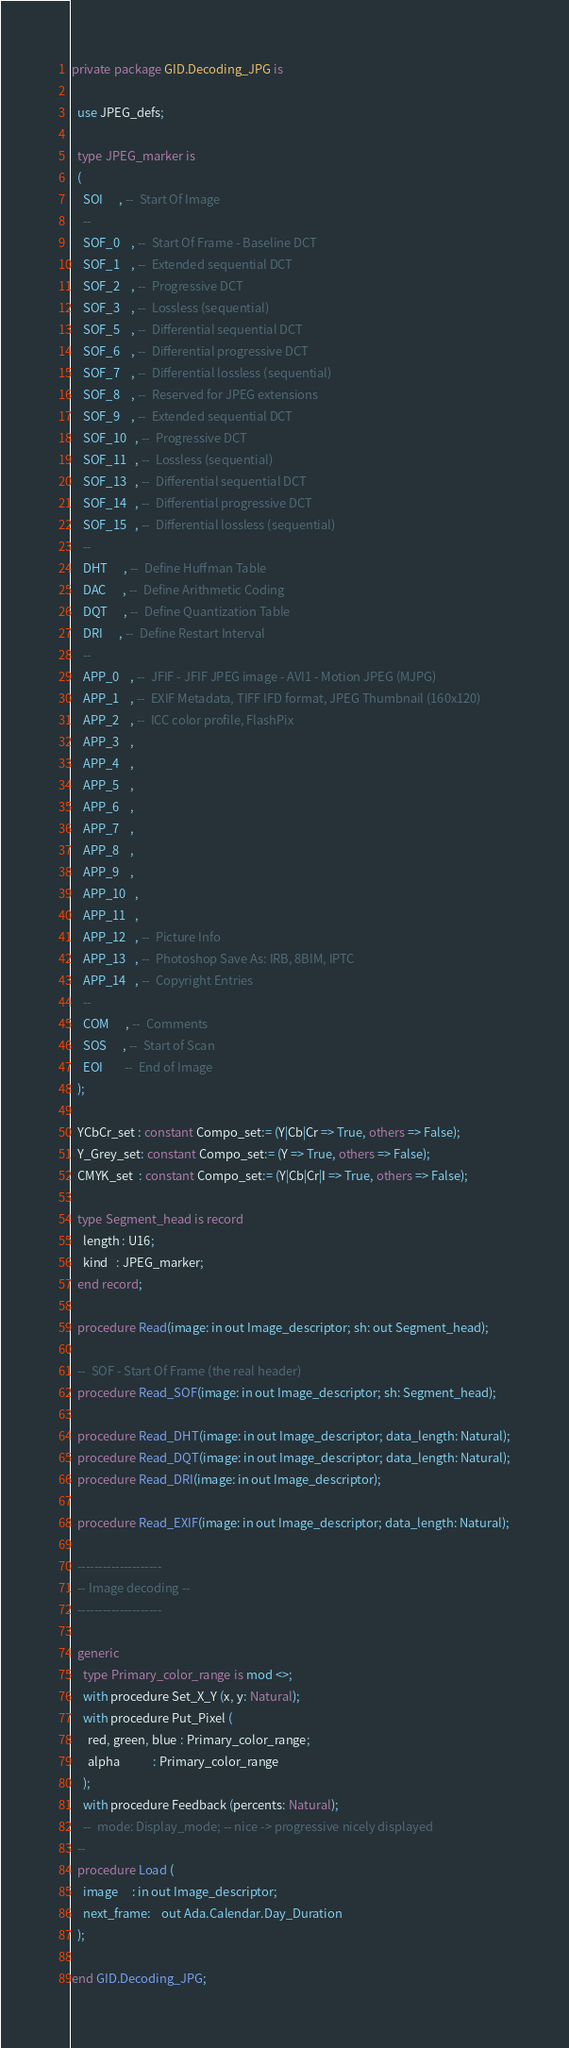<code> <loc_0><loc_0><loc_500><loc_500><_Ada_>private package GID.Decoding_JPG is

  use JPEG_defs;

  type JPEG_marker is
  (
    SOI      , --  Start Of Image
    --
    SOF_0    , --  Start Of Frame - Baseline DCT
    SOF_1    , --  Extended sequential DCT
    SOF_2    , --  Progressive DCT
    SOF_3    , --  Lossless (sequential)
    SOF_5    , --  Differential sequential DCT
    SOF_6    , --  Differential progressive DCT
    SOF_7    , --  Differential lossless (sequential)
    SOF_8    , --  Reserved for JPEG extensions
    SOF_9    , --  Extended sequential DCT
    SOF_10   , --  Progressive DCT
    SOF_11   , --  Lossless (sequential)
    SOF_13   , --  Differential sequential DCT
    SOF_14   , --  Differential progressive DCT
    SOF_15   , --  Differential lossless (sequential)
    --
    DHT      , --  Define Huffman Table
    DAC      , --  Define Arithmetic Coding
    DQT      , --  Define Quantization Table
    DRI      , --  Define Restart Interval
    --
    APP_0    , --  JFIF - JFIF JPEG image - AVI1 - Motion JPEG (MJPG)
    APP_1    , --  EXIF Metadata, TIFF IFD format, JPEG Thumbnail (160x120)
    APP_2    , --  ICC color profile, FlashPix
    APP_3    ,
    APP_4    ,
    APP_5    ,
    APP_6    ,
    APP_7    ,
    APP_8    ,
    APP_9    ,
    APP_10   ,
    APP_11   ,
    APP_12   , --  Picture Info
    APP_13   , --  Photoshop Save As: IRB, 8BIM, IPTC
    APP_14   , --  Copyright Entries
    --
    COM      , --  Comments
    SOS      , --  Start of Scan
    EOI        --  End of Image
  );

  YCbCr_set : constant Compo_set:= (Y|Cb|Cr => True, others => False);
  Y_Grey_set: constant Compo_set:= (Y => True, others => False);
  CMYK_set  : constant Compo_set:= (Y|Cb|Cr|I => True, others => False);

  type Segment_head is record
    length : U16;
    kind   : JPEG_marker;
  end record;

  procedure Read(image: in out Image_descriptor; sh: out Segment_head);

  --  SOF - Start Of Frame (the real header)
  procedure Read_SOF(image: in out Image_descriptor; sh: Segment_head);

  procedure Read_DHT(image: in out Image_descriptor; data_length: Natural);
  procedure Read_DQT(image: in out Image_descriptor; data_length: Natural);
  procedure Read_DRI(image: in out Image_descriptor);

  procedure Read_EXIF(image: in out Image_descriptor; data_length: Natural);

  --------------------
  -- Image decoding --
  --------------------

  generic
    type Primary_color_range is mod <>;
    with procedure Set_X_Y (x, y: Natural);
    with procedure Put_Pixel (
      red, green, blue : Primary_color_range;
      alpha            : Primary_color_range
    );
    with procedure Feedback (percents: Natural);
    --  mode: Display_mode; -- nice -> progressive nicely displayed
  --
  procedure Load (
    image     : in out Image_descriptor;
    next_frame:    out Ada.Calendar.Day_Duration
  );

end GID.Decoding_JPG;
</code> 